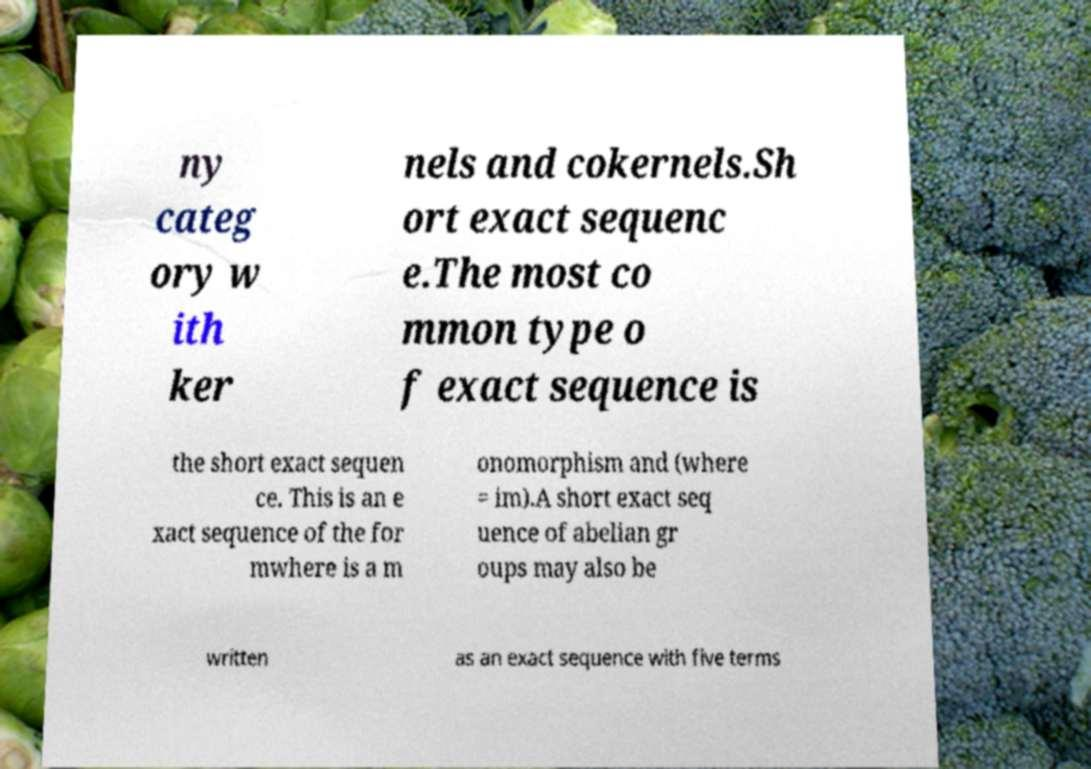Can you accurately transcribe the text from the provided image for me? ny categ ory w ith ker nels and cokernels.Sh ort exact sequenc e.The most co mmon type o f exact sequence is the short exact sequen ce. This is an e xact sequence of the for mwhere is a m onomorphism and (where = im).A short exact seq uence of abelian gr oups may also be written as an exact sequence with five terms 